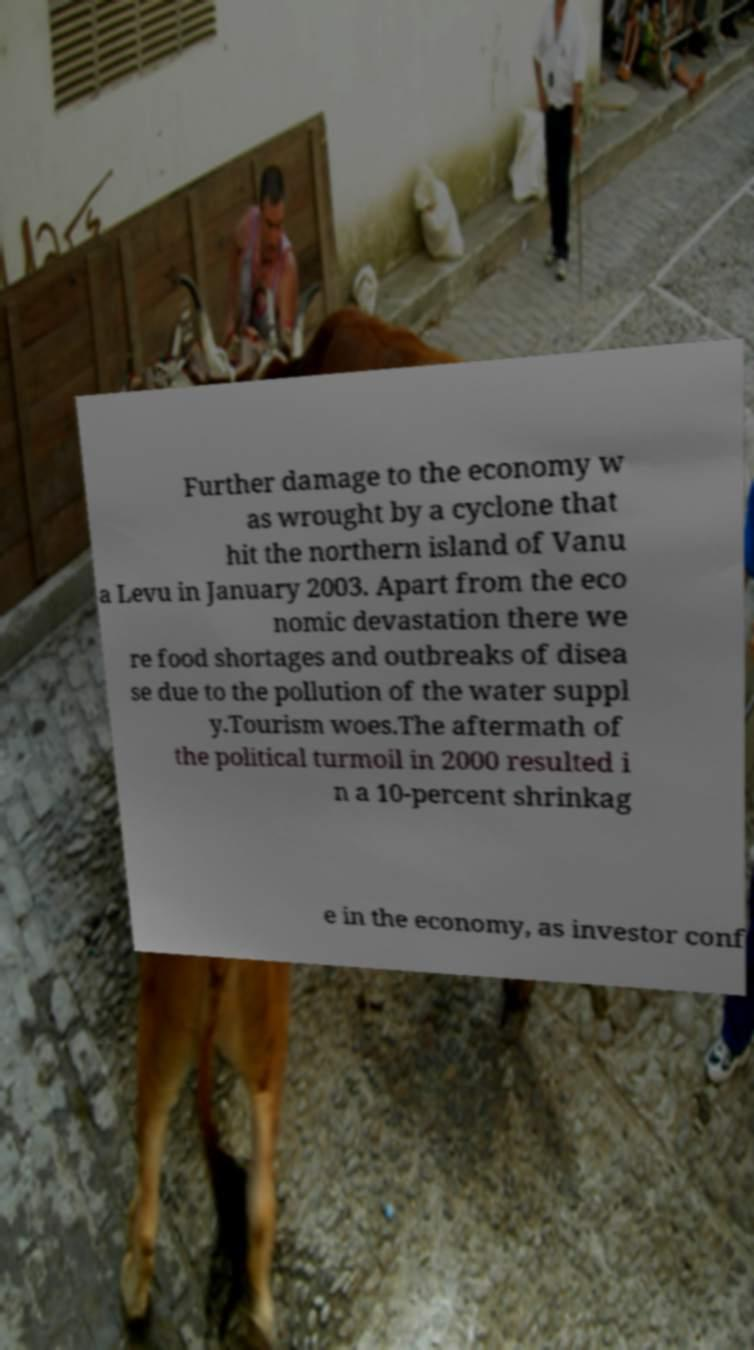I need the written content from this picture converted into text. Can you do that? Further damage to the economy w as wrought by a cyclone that hit the northern island of Vanu a Levu in January 2003. Apart from the eco nomic devastation there we re food shortages and outbreaks of disea se due to the pollution of the water suppl y.Tourism woes.The aftermath of the political turmoil in 2000 resulted i n a 10-percent shrinkag e in the economy, as investor conf 